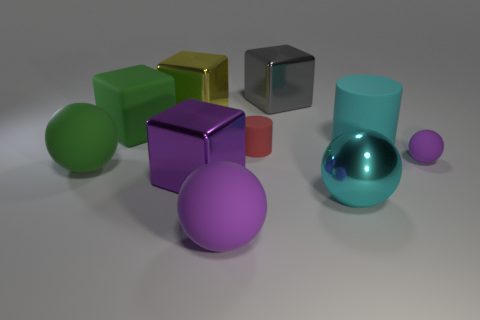Subtract 1 balls. How many balls are left? 3 Subtract all brown cylinders. Subtract all yellow blocks. How many cylinders are left? 2 Subtract all cylinders. How many objects are left? 8 Add 1 green matte objects. How many green matte objects are left? 3 Add 1 yellow cylinders. How many yellow cylinders exist? 1 Subtract 0 green cylinders. How many objects are left? 10 Subtract all large brown rubber blocks. Subtract all big purple cubes. How many objects are left? 9 